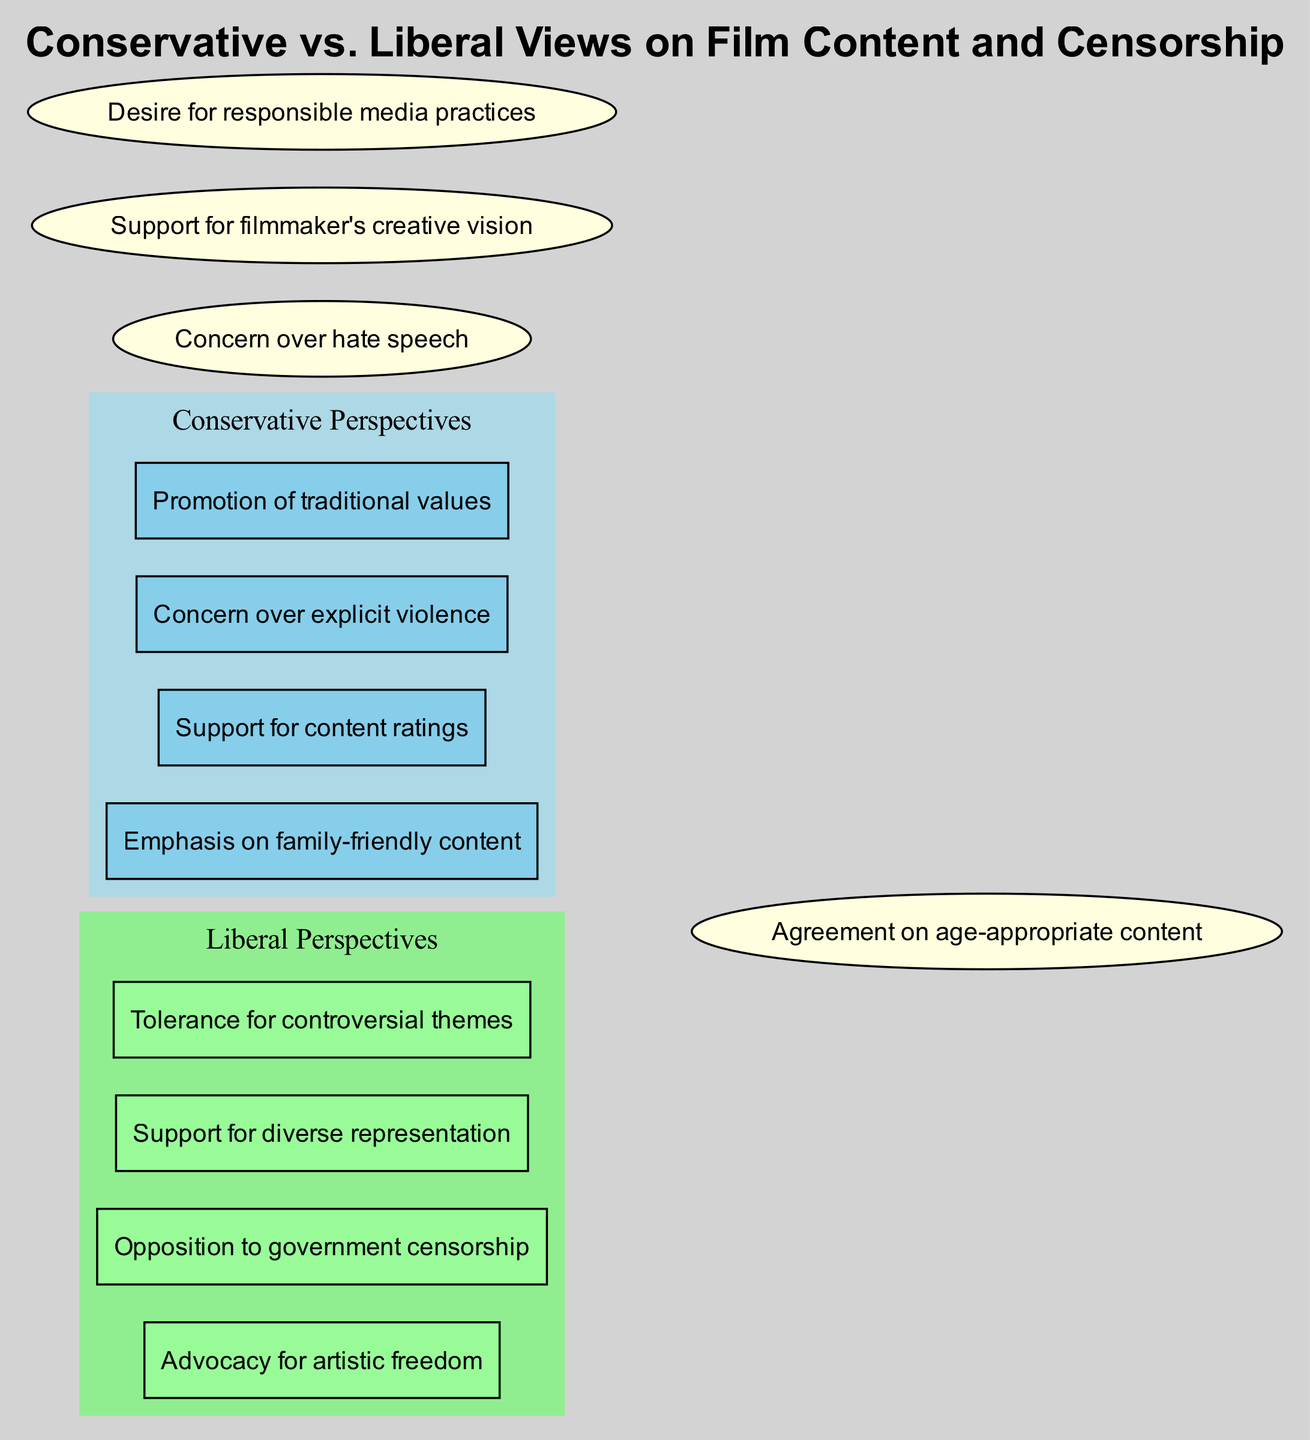What are the four elements of Conservative Perspectives? The diagram lists "Emphasis on family-friendly content," "Support for content ratings," "Concern over explicit violence," and "Promotion of traditional values" as the four elements in the Conservative Perspectives section.
Answer: Emphasis on family-friendly content, Support for content ratings, Concern over explicit violence, Promotion of traditional values How many elements are listed under Liberal Perspectives? There are four elements presented in the Liberal Perspectives section of the diagram, which are "Advocacy for artistic freedom," "Opposition to government censorship," "Support for diverse representation," and "Tolerance for controversial themes."
Answer: 4 What do both Conservatives and Liberals agree upon regarding film content? The overlapping section of the diagram highlights "Agreement on age-appropriate content," which indicates a shared concern for content that is suitable for different age groups.
Answer: Agreement on age-appropriate content Which perspective concerns itself with hate speech? The overlapping elements show that both Conservative and Liberal perspectives are concerned over hate speech, reflecting a common ground in the desire to prevent harmful expressions.
Answer: Both Name the element that represents a shared concern for media practices. Among the overlapping elements, "Desire for responsible media practices" is noted, indicating that both sides acknowledge the importance of responsibility in film and media production.
Answer: Desire for responsible media practices How many total unique elements are there in the Conservative and Liberal Perspectives combined? The diagram indicates that there are a total of eight unique elements when the four conservative elements are combined with the four liberal elements.
Answer: 8 